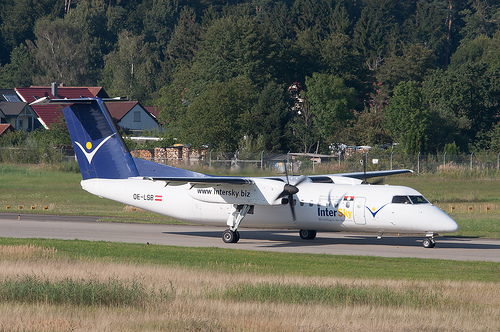How does the green vegetation contrast with the airplane's white and blue colors? The green vegetation provides a natural and vibrant backdrop that contrasts sharply against the airplane's white and blue colors, making the aircraft stand out prominently. This contrast can help in highlighting the presence of the plane within its natural surroundings and creates a visually appealing scene. 